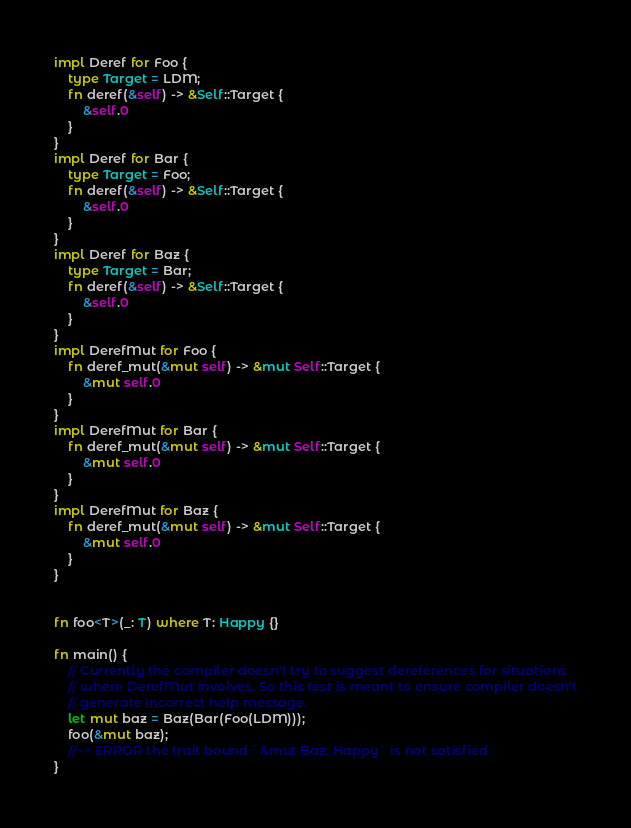<code> <loc_0><loc_0><loc_500><loc_500><_Rust_>impl Deref for Foo {
    type Target = LDM;
    fn deref(&self) -> &Self::Target {
        &self.0
    }
}
impl Deref for Bar {
    type Target = Foo;
    fn deref(&self) -> &Self::Target {
        &self.0
    }
}
impl Deref for Baz {
    type Target = Bar;
    fn deref(&self) -> &Self::Target {
        &self.0
    }
}
impl DerefMut for Foo {
    fn deref_mut(&mut self) -> &mut Self::Target {
        &mut self.0
    }
}
impl DerefMut for Bar {
    fn deref_mut(&mut self) -> &mut Self::Target {
        &mut self.0
    }
}
impl DerefMut for Baz {
    fn deref_mut(&mut self) -> &mut Self::Target {
        &mut self.0
    }
}


fn foo<T>(_: T) where T: Happy {}

fn main() {
    // Currently the compiler doesn't try to suggest dereferences for situations
    // where DerefMut involves. So this test is meant to ensure compiler doesn't
    // generate incorrect help message.
    let mut baz = Baz(Bar(Foo(LDM)));
    foo(&mut baz);
    //~^ ERROR the trait bound `&mut Baz: Happy` is not satisfied
}
</code> 